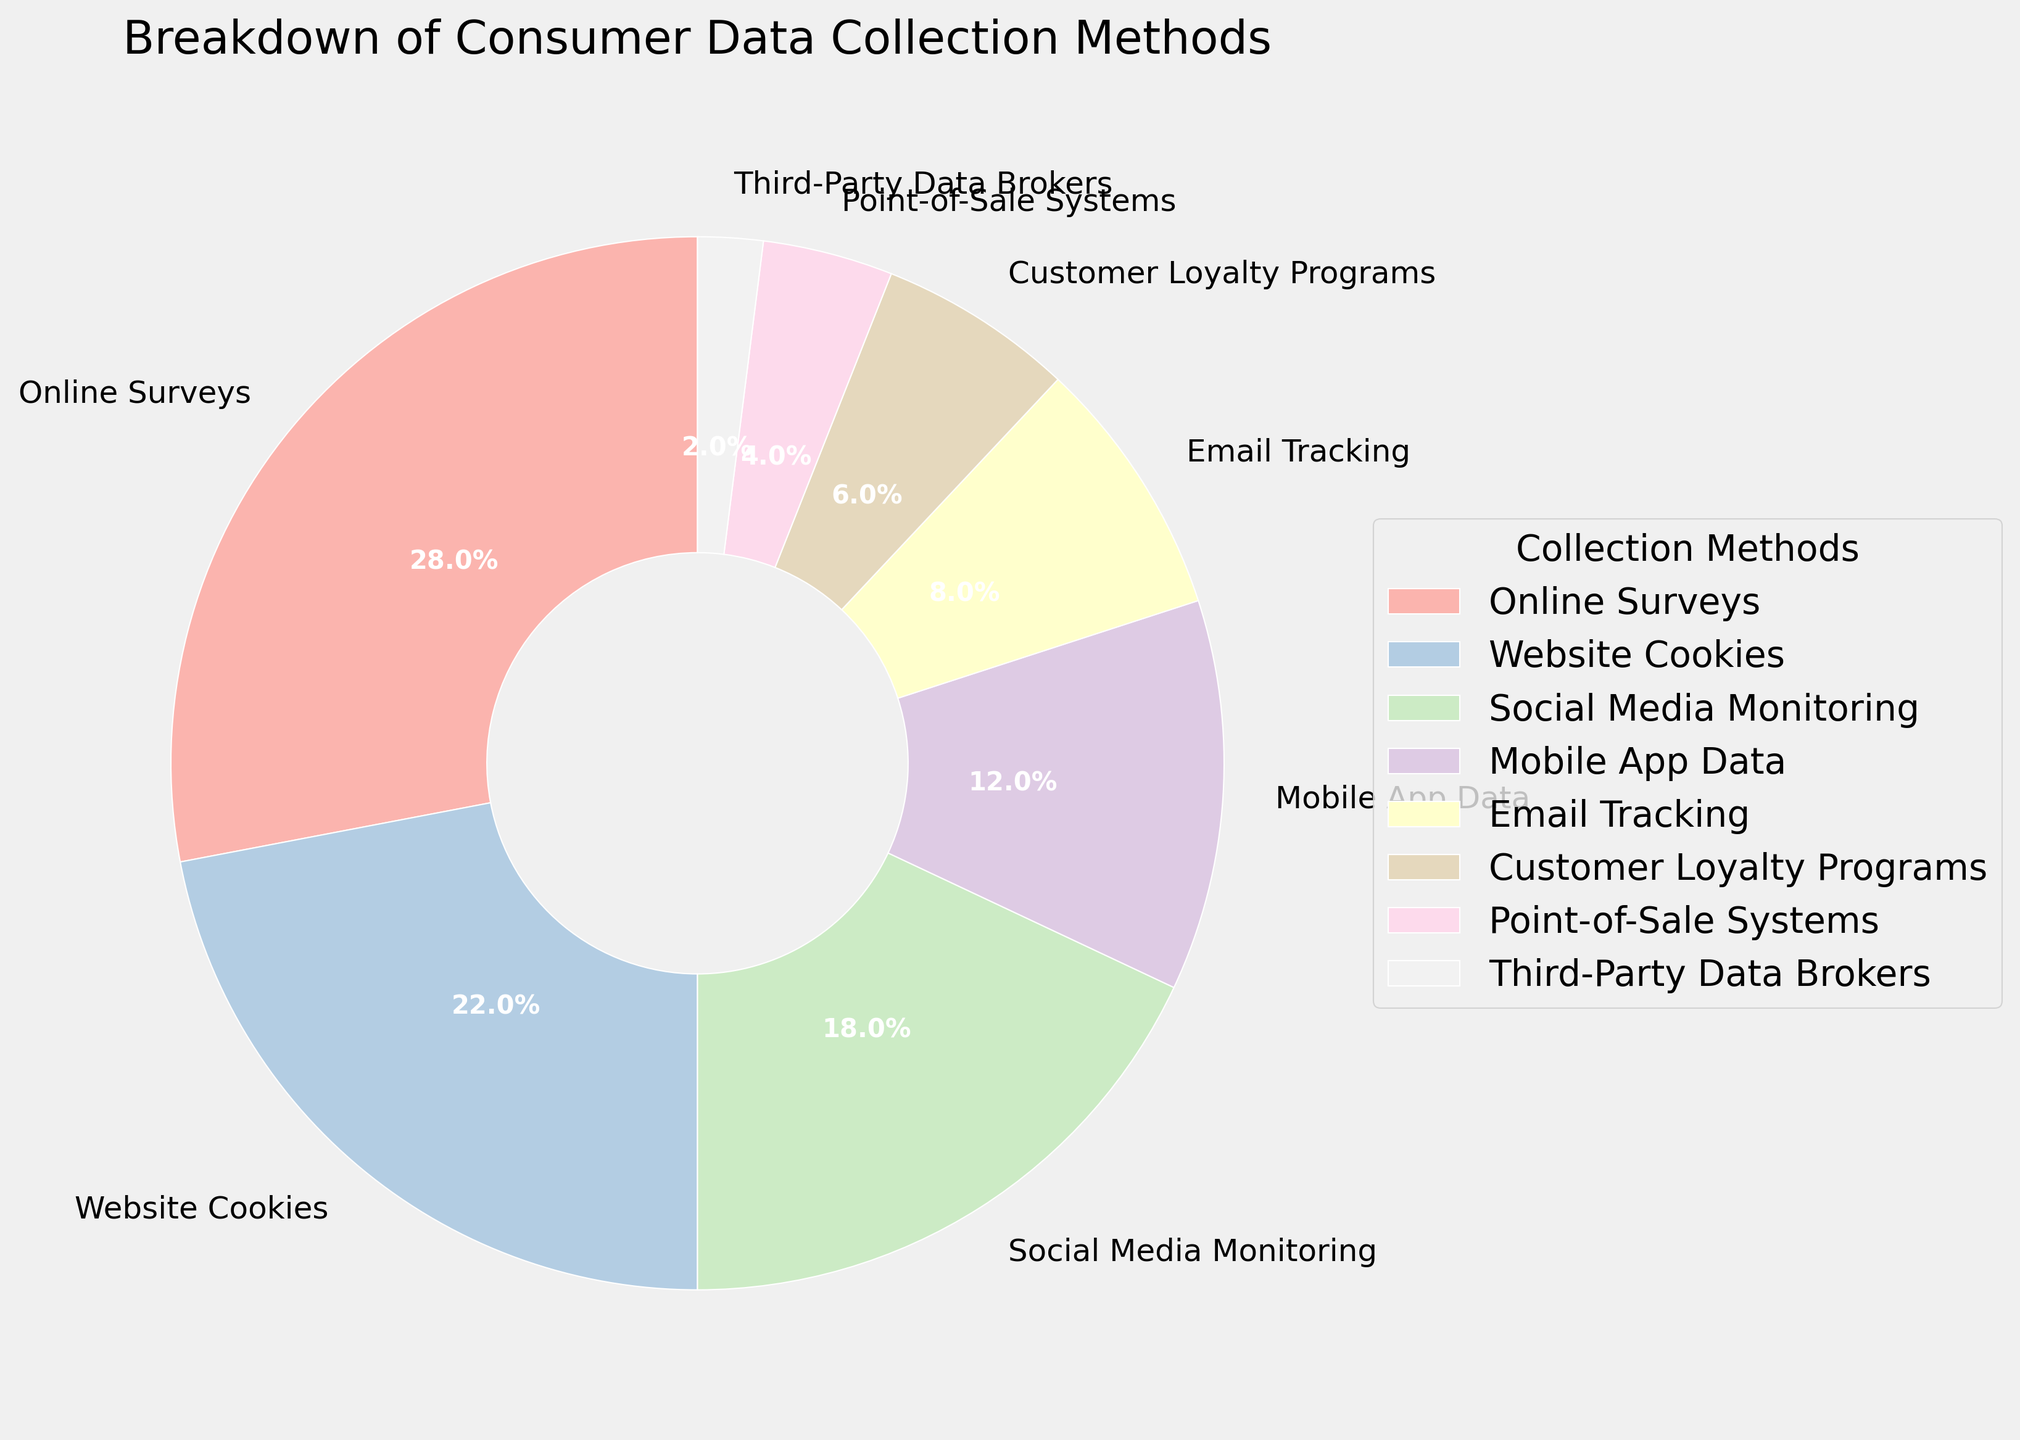Which method collects the largest percentage of consumer data? According to the pie chart, "Online Surveys" has the largest slice, indicating it collects the highest percentage of consumer data.
Answer: Online Surveys How much more data is collected through website cookies compared to customer loyalty programs? "Website Cookies" collects 22% while "Customer Loyalty Programs" collect 6%. Subtracting these two percentages (22% - 6%) gives us the difference.
Answer: 16% Which data collection method is used the least? Based on the pie chart, "Third-Party Data Brokers" have the smallest slice, indicating it is used the least for data collection.
Answer: Third-Party Data Brokers What is the combined percentage of data collected through mobile app data and email tracking? From the chart, "Mobile App Data" collects 12% and "Email Tracking" collects 8%. Adding these together gives 12% + 8%.
Answer: 20% What is the difference in data collection between social media monitoring and point-of-sale systems? "Social Media Monitoring" collects 18% and "Point-of-Sale Systems" collect 4%. Subtracting these percentages (18% - 4%) provides the difference.
Answer: 14% Are email tracking and customer loyalty programs equally used for data collection? "Email Tracking" collects 8% and "Customer Loyalty Programs" collect 6%. Since 8% is greater than 6%, they are not equally used.
Answer: No Which is collected more: mobile app data or social media monitoring? According to the chart, "Social Media Monitoring" collects 18% while "Mobile App Data" collects 12%. Therefore, social media monitoring collects more data.
Answer: Social Media Monitoring What is the sum of the percentages collected by all the methods combined? Adding up all the percentages listed (28% + 22% + 18% + 12% + 8% + 6% + 4% + 2%) generates the sum.
Answer: 100% Is the percentage of data collected through online surveys higher than the combined percentage of customer loyalty programs and third-party data brokers? "Online Surveys" collect 28%. The combined percentage of "Customer Loyalty Programs" (6%) and "Third-Party Data Brokers" (2%) is 6% + 2% = 8%. 28% is greater than 8%.
Answer: Yes Which segment represents data collected through point-of-sale systems based on its color, and what is its percentage? In the pie chart, each segment is colored differently. The segment color representing "Point-of-Sale Systems" is visually distinguishable, and its corresponding percentage is 4%.
Answer: 4% 